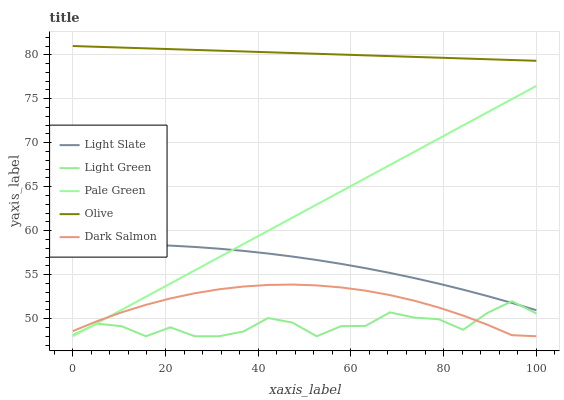Does Light Green have the minimum area under the curve?
Answer yes or no. Yes. Does Olive have the maximum area under the curve?
Answer yes or no. Yes. Does Pale Green have the minimum area under the curve?
Answer yes or no. No. Does Pale Green have the maximum area under the curve?
Answer yes or no. No. Is Pale Green the smoothest?
Answer yes or no. Yes. Is Light Green the roughest?
Answer yes or no. Yes. Is Olive the smoothest?
Answer yes or no. No. Is Olive the roughest?
Answer yes or no. No. Does Olive have the lowest value?
Answer yes or no. No. Does Olive have the highest value?
Answer yes or no. Yes. Does Pale Green have the highest value?
Answer yes or no. No. Is Dark Salmon less than Light Slate?
Answer yes or no. Yes. Is Light Slate greater than Dark Salmon?
Answer yes or no. Yes. Does Light Green intersect Pale Green?
Answer yes or no. Yes. Is Light Green less than Pale Green?
Answer yes or no. No. Is Light Green greater than Pale Green?
Answer yes or no. No. Does Dark Salmon intersect Light Slate?
Answer yes or no. No. 